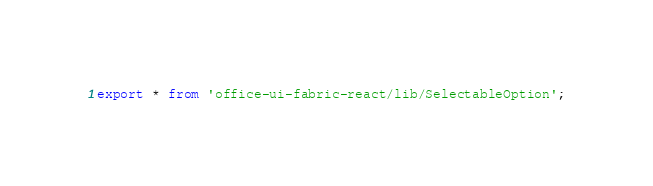<code> <loc_0><loc_0><loc_500><loc_500><_TypeScript_>export * from 'office-ui-fabric-react/lib/SelectableOption';
</code> 